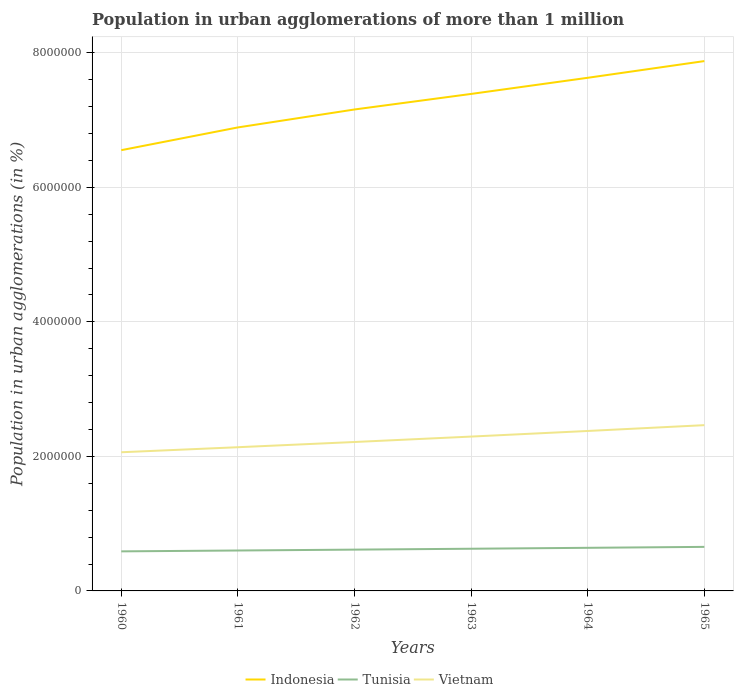Across all years, what is the maximum population in urban agglomerations in Tunisia?
Give a very brief answer. 5.88e+05. What is the total population in urban agglomerations in Vietnam in the graph?
Make the answer very short. -1.58e+05. What is the difference between the highest and the second highest population in urban agglomerations in Indonesia?
Keep it short and to the point. 1.32e+06. What is the difference between the highest and the lowest population in urban agglomerations in Tunisia?
Provide a succinct answer. 3. Is the population in urban agglomerations in Tunisia strictly greater than the population in urban agglomerations in Vietnam over the years?
Your answer should be compact. Yes. How many lines are there?
Provide a succinct answer. 3. What is the title of the graph?
Keep it short and to the point. Population in urban agglomerations of more than 1 million. What is the label or title of the Y-axis?
Give a very brief answer. Population in urban agglomerations (in %). What is the Population in urban agglomerations (in %) in Indonesia in 1960?
Your answer should be very brief. 6.55e+06. What is the Population in urban agglomerations (in %) in Tunisia in 1960?
Your answer should be very brief. 5.88e+05. What is the Population in urban agglomerations (in %) of Vietnam in 1960?
Make the answer very short. 2.06e+06. What is the Population in urban agglomerations (in %) of Indonesia in 1961?
Your answer should be very brief. 6.89e+06. What is the Population in urban agglomerations (in %) in Tunisia in 1961?
Provide a succinct answer. 6.01e+05. What is the Population in urban agglomerations (in %) of Vietnam in 1961?
Provide a short and direct response. 2.14e+06. What is the Population in urban agglomerations (in %) of Indonesia in 1962?
Your response must be concise. 7.16e+06. What is the Population in urban agglomerations (in %) in Tunisia in 1962?
Offer a very short reply. 6.14e+05. What is the Population in urban agglomerations (in %) of Vietnam in 1962?
Your answer should be compact. 2.21e+06. What is the Population in urban agglomerations (in %) in Indonesia in 1963?
Provide a succinct answer. 7.39e+06. What is the Population in urban agglomerations (in %) of Tunisia in 1963?
Keep it short and to the point. 6.27e+05. What is the Population in urban agglomerations (in %) of Vietnam in 1963?
Provide a short and direct response. 2.29e+06. What is the Population in urban agglomerations (in %) of Indonesia in 1964?
Your answer should be compact. 7.63e+06. What is the Population in urban agglomerations (in %) of Tunisia in 1964?
Offer a very short reply. 6.41e+05. What is the Population in urban agglomerations (in %) of Vietnam in 1964?
Offer a very short reply. 2.38e+06. What is the Population in urban agglomerations (in %) of Indonesia in 1965?
Your answer should be very brief. 7.88e+06. What is the Population in urban agglomerations (in %) in Tunisia in 1965?
Give a very brief answer. 6.55e+05. What is the Population in urban agglomerations (in %) of Vietnam in 1965?
Make the answer very short. 2.46e+06. Across all years, what is the maximum Population in urban agglomerations (in %) of Indonesia?
Offer a terse response. 7.88e+06. Across all years, what is the maximum Population in urban agglomerations (in %) in Tunisia?
Offer a very short reply. 6.55e+05. Across all years, what is the maximum Population in urban agglomerations (in %) in Vietnam?
Your answer should be compact. 2.46e+06. Across all years, what is the minimum Population in urban agglomerations (in %) of Indonesia?
Give a very brief answer. 6.55e+06. Across all years, what is the minimum Population in urban agglomerations (in %) of Tunisia?
Offer a very short reply. 5.88e+05. Across all years, what is the minimum Population in urban agglomerations (in %) in Vietnam?
Your answer should be compact. 2.06e+06. What is the total Population in urban agglomerations (in %) of Indonesia in the graph?
Offer a very short reply. 4.35e+07. What is the total Population in urban agglomerations (in %) in Tunisia in the graph?
Offer a very short reply. 3.73e+06. What is the total Population in urban agglomerations (in %) in Vietnam in the graph?
Keep it short and to the point. 1.36e+07. What is the difference between the Population in urban agglomerations (in %) of Indonesia in 1960 and that in 1961?
Offer a very short reply. -3.38e+05. What is the difference between the Population in urban agglomerations (in %) in Tunisia in 1960 and that in 1961?
Keep it short and to the point. -1.27e+04. What is the difference between the Population in urban agglomerations (in %) in Vietnam in 1960 and that in 1961?
Provide a succinct answer. -7.48e+04. What is the difference between the Population in urban agglomerations (in %) of Indonesia in 1960 and that in 1962?
Offer a terse response. -6.05e+05. What is the difference between the Population in urban agglomerations (in %) in Tunisia in 1960 and that in 1962?
Give a very brief answer. -2.58e+04. What is the difference between the Population in urban agglomerations (in %) of Vietnam in 1960 and that in 1962?
Make the answer very short. -1.52e+05. What is the difference between the Population in urban agglomerations (in %) of Indonesia in 1960 and that in 1963?
Provide a short and direct response. -8.36e+05. What is the difference between the Population in urban agglomerations (in %) in Tunisia in 1960 and that in 1963?
Provide a short and direct response. -3.91e+04. What is the difference between the Population in urban agglomerations (in %) in Vietnam in 1960 and that in 1963?
Give a very brief answer. -2.33e+05. What is the difference between the Population in urban agglomerations (in %) of Indonesia in 1960 and that in 1964?
Give a very brief answer. -1.08e+06. What is the difference between the Population in urban agglomerations (in %) of Tunisia in 1960 and that in 1964?
Make the answer very short. -5.27e+04. What is the difference between the Population in urban agglomerations (in %) in Vietnam in 1960 and that in 1964?
Your response must be concise. -3.16e+05. What is the difference between the Population in urban agglomerations (in %) of Indonesia in 1960 and that in 1965?
Offer a terse response. -1.32e+06. What is the difference between the Population in urban agglomerations (in %) in Tunisia in 1960 and that in 1965?
Ensure brevity in your answer.  -6.66e+04. What is the difference between the Population in urban agglomerations (in %) in Vietnam in 1960 and that in 1965?
Give a very brief answer. -4.03e+05. What is the difference between the Population in urban agglomerations (in %) in Indonesia in 1961 and that in 1962?
Ensure brevity in your answer.  -2.67e+05. What is the difference between the Population in urban agglomerations (in %) in Tunisia in 1961 and that in 1962?
Ensure brevity in your answer.  -1.30e+04. What is the difference between the Population in urban agglomerations (in %) in Vietnam in 1961 and that in 1962?
Your answer should be very brief. -7.76e+04. What is the difference between the Population in urban agglomerations (in %) in Indonesia in 1961 and that in 1963?
Give a very brief answer. -4.98e+05. What is the difference between the Population in urban agglomerations (in %) in Tunisia in 1961 and that in 1963?
Give a very brief answer. -2.63e+04. What is the difference between the Population in urban agglomerations (in %) in Vietnam in 1961 and that in 1963?
Offer a very short reply. -1.58e+05. What is the difference between the Population in urban agglomerations (in %) of Indonesia in 1961 and that in 1964?
Your answer should be compact. -7.38e+05. What is the difference between the Population in urban agglomerations (in %) in Tunisia in 1961 and that in 1964?
Your answer should be compact. -4.00e+04. What is the difference between the Population in urban agglomerations (in %) of Vietnam in 1961 and that in 1964?
Provide a short and direct response. -2.42e+05. What is the difference between the Population in urban agglomerations (in %) in Indonesia in 1961 and that in 1965?
Your answer should be very brief. -9.86e+05. What is the difference between the Population in urban agglomerations (in %) in Tunisia in 1961 and that in 1965?
Offer a terse response. -5.38e+04. What is the difference between the Population in urban agglomerations (in %) of Vietnam in 1961 and that in 1965?
Provide a succinct answer. -3.28e+05. What is the difference between the Population in urban agglomerations (in %) of Indonesia in 1962 and that in 1963?
Your answer should be very brief. -2.31e+05. What is the difference between the Population in urban agglomerations (in %) in Tunisia in 1962 and that in 1963?
Make the answer very short. -1.33e+04. What is the difference between the Population in urban agglomerations (in %) in Vietnam in 1962 and that in 1963?
Make the answer very short. -8.05e+04. What is the difference between the Population in urban agglomerations (in %) of Indonesia in 1962 and that in 1964?
Your response must be concise. -4.71e+05. What is the difference between the Population in urban agglomerations (in %) of Tunisia in 1962 and that in 1964?
Offer a very short reply. -2.69e+04. What is the difference between the Population in urban agglomerations (in %) in Vietnam in 1962 and that in 1964?
Offer a terse response. -1.64e+05. What is the difference between the Population in urban agglomerations (in %) in Indonesia in 1962 and that in 1965?
Give a very brief answer. -7.20e+05. What is the difference between the Population in urban agglomerations (in %) of Tunisia in 1962 and that in 1965?
Your response must be concise. -4.08e+04. What is the difference between the Population in urban agglomerations (in %) in Vietnam in 1962 and that in 1965?
Provide a succinct answer. -2.50e+05. What is the difference between the Population in urban agglomerations (in %) in Indonesia in 1963 and that in 1964?
Give a very brief answer. -2.40e+05. What is the difference between the Population in urban agglomerations (in %) of Tunisia in 1963 and that in 1964?
Make the answer very short. -1.36e+04. What is the difference between the Population in urban agglomerations (in %) in Vietnam in 1963 and that in 1964?
Your answer should be compact. -8.35e+04. What is the difference between the Population in urban agglomerations (in %) in Indonesia in 1963 and that in 1965?
Keep it short and to the point. -4.88e+05. What is the difference between the Population in urban agglomerations (in %) of Tunisia in 1963 and that in 1965?
Provide a succinct answer. -2.75e+04. What is the difference between the Population in urban agglomerations (in %) of Vietnam in 1963 and that in 1965?
Ensure brevity in your answer.  -1.70e+05. What is the difference between the Population in urban agglomerations (in %) in Indonesia in 1964 and that in 1965?
Make the answer very short. -2.48e+05. What is the difference between the Population in urban agglomerations (in %) of Tunisia in 1964 and that in 1965?
Provide a succinct answer. -1.39e+04. What is the difference between the Population in urban agglomerations (in %) of Vietnam in 1964 and that in 1965?
Give a very brief answer. -8.63e+04. What is the difference between the Population in urban agglomerations (in %) in Indonesia in 1960 and the Population in urban agglomerations (in %) in Tunisia in 1961?
Offer a very short reply. 5.95e+06. What is the difference between the Population in urban agglomerations (in %) of Indonesia in 1960 and the Population in urban agglomerations (in %) of Vietnam in 1961?
Your response must be concise. 4.42e+06. What is the difference between the Population in urban agglomerations (in %) in Tunisia in 1960 and the Population in urban agglomerations (in %) in Vietnam in 1961?
Keep it short and to the point. -1.55e+06. What is the difference between the Population in urban agglomerations (in %) of Indonesia in 1960 and the Population in urban agglomerations (in %) of Tunisia in 1962?
Provide a succinct answer. 5.94e+06. What is the difference between the Population in urban agglomerations (in %) in Indonesia in 1960 and the Population in urban agglomerations (in %) in Vietnam in 1962?
Keep it short and to the point. 4.34e+06. What is the difference between the Population in urban agglomerations (in %) of Tunisia in 1960 and the Population in urban agglomerations (in %) of Vietnam in 1962?
Your response must be concise. -1.63e+06. What is the difference between the Population in urban agglomerations (in %) of Indonesia in 1960 and the Population in urban agglomerations (in %) of Tunisia in 1963?
Your response must be concise. 5.93e+06. What is the difference between the Population in urban agglomerations (in %) of Indonesia in 1960 and the Population in urban agglomerations (in %) of Vietnam in 1963?
Offer a terse response. 4.26e+06. What is the difference between the Population in urban agglomerations (in %) in Tunisia in 1960 and the Population in urban agglomerations (in %) in Vietnam in 1963?
Your response must be concise. -1.71e+06. What is the difference between the Population in urban agglomerations (in %) in Indonesia in 1960 and the Population in urban agglomerations (in %) in Tunisia in 1964?
Your answer should be compact. 5.91e+06. What is the difference between the Population in urban agglomerations (in %) of Indonesia in 1960 and the Population in urban agglomerations (in %) of Vietnam in 1964?
Your response must be concise. 4.17e+06. What is the difference between the Population in urban agglomerations (in %) of Tunisia in 1960 and the Population in urban agglomerations (in %) of Vietnam in 1964?
Ensure brevity in your answer.  -1.79e+06. What is the difference between the Population in urban agglomerations (in %) of Indonesia in 1960 and the Population in urban agglomerations (in %) of Tunisia in 1965?
Give a very brief answer. 5.90e+06. What is the difference between the Population in urban agglomerations (in %) of Indonesia in 1960 and the Population in urban agglomerations (in %) of Vietnam in 1965?
Offer a terse response. 4.09e+06. What is the difference between the Population in urban agglomerations (in %) of Tunisia in 1960 and the Population in urban agglomerations (in %) of Vietnam in 1965?
Your answer should be very brief. -1.88e+06. What is the difference between the Population in urban agglomerations (in %) in Indonesia in 1961 and the Population in urban agglomerations (in %) in Tunisia in 1962?
Your answer should be very brief. 6.28e+06. What is the difference between the Population in urban agglomerations (in %) of Indonesia in 1961 and the Population in urban agglomerations (in %) of Vietnam in 1962?
Provide a short and direct response. 4.68e+06. What is the difference between the Population in urban agglomerations (in %) in Tunisia in 1961 and the Population in urban agglomerations (in %) in Vietnam in 1962?
Your answer should be compact. -1.61e+06. What is the difference between the Population in urban agglomerations (in %) of Indonesia in 1961 and the Population in urban agglomerations (in %) of Tunisia in 1963?
Give a very brief answer. 6.26e+06. What is the difference between the Population in urban agglomerations (in %) of Indonesia in 1961 and the Population in urban agglomerations (in %) of Vietnam in 1963?
Give a very brief answer. 4.60e+06. What is the difference between the Population in urban agglomerations (in %) in Tunisia in 1961 and the Population in urban agglomerations (in %) in Vietnam in 1963?
Your answer should be compact. -1.69e+06. What is the difference between the Population in urban agglomerations (in %) in Indonesia in 1961 and the Population in urban agglomerations (in %) in Tunisia in 1964?
Your answer should be compact. 6.25e+06. What is the difference between the Population in urban agglomerations (in %) of Indonesia in 1961 and the Population in urban agglomerations (in %) of Vietnam in 1964?
Make the answer very short. 4.51e+06. What is the difference between the Population in urban agglomerations (in %) of Tunisia in 1961 and the Population in urban agglomerations (in %) of Vietnam in 1964?
Keep it short and to the point. -1.78e+06. What is the difference between the Population in urban agglomerations (in %) in Indonesia in 1961 and the Population in urban agglomerations (in %) in Tunisia in 1965?
Keep it short and to the point. 6.24e+06. What is the difference between the Population in urban agglomerations (in %) of Indonesia in 1961 and the Population in urban agglomerations (in %) of Vietnam in 1965?
Your answer should be very brief. 4.43e+06. What is the difference between the Population in urban agglomerations (in %) in Tunisia in 1961 and the Population in urban agglomerations (in %) in Vietnam in 1965?
Provide a short and direct response. -1.86e+06. What is the difference between the Population in urban agglomerations (in %) in Indonesia in 1962 and the Population in urban agglomerations (in %) in Tunisia in 1963?
Your response must be concise. 6.53e+06. What is the difference between the Population in urban agglomerations (in %) in Indonesia in 1962 and the Population in urban agglomerations (in %) in Vietnam in 1963?
Give a very brief answer. 4.86e+06. What is the difference between the Population in urban agglomerations (in %) of Tunisia in 1962 and the Population in urban agglomerations (in %) of Vietnam in 1963?
Your answer should be compact. -1.68e+06. What is the difference between the Population in urban agglomerations (in %) of Indonesia in 1962 and the Population in urban agglomerations (in %) of Tunisia in 1964?
Make the answer very short. 6.52e+06. What is the difference between the Population in urban agglomerations (in %) of Indonesia in 1962 and the Population in urban agglomerations (in %) of Vietnam in 1964?
Provide a succinct answer. 4.78e+06. What is the difference between the Population in urban agglomerations (in %) in Tunisia in 1962 and the Population in urban agglomerations (in %) in Vietnam in 1964?
Provide a short and direct response. -1.76e+06. What is the difference between the Population in urban agglomerations (in %) of Indonesia in 1962 and the Population in urban agglomerations (in %) of Tunisia in 1965?
Your answer should be very brief. 6.50e+06. What is the difference between the Population in urban agglomerations (in %) in Indonesia in 1962 and the Population in urban agglomerations (in %) in Vietnam in 1965?
Offer a terse response. 4.69e+06. What is the difference between the Population in urban agglomerations (in %) in Tunisia in 1962 and the Population in urban agglomerations (in %) in Vietnam in 1965?
Your answer should be very brief. -1.85e+06. What is the difference between the Population in urban agglomerations (in %) in Indonesia in 1963 and the Population in urban agglomerations (in %) in Tunisia in 1964?
Keep it short and to the point. 6.75e+06. What is the difference between the Population in urban agglomerations (in %) in Indonesia in 1963 and the Population in urban agglomerations (in %) in Vietnam in 1964?
Offer a terse response. 5.01e+06. What is the difference between the Population in urban agglomerations (in %) of Tunisia in 1963 and the Population in urban agglomerations (in %) of Vietnam in 1964?
Provide a short and direct response. -1.75e+06. What is the difference between the Population in urban agglomerations (in %) of Indonesia in 1963 and the Population in urban agglomerations (in %) of Tunisia in 1965?
Provide a short and direct response. 6.73e+06. What is the difference between the Population in urban agglomerations (in %) in Indonesia in 1963 and the Population in urban agglomerations (in %) in Vietnam in 1965?
Provide a short and direct response. 4.92e+06. What is the difference between the Population in urban agglomerations (in %) in Tunisia in 1963 and the Population in urban agglomerations (in %) in Vietnam in 1965?
Ensure brevity in your answer.  -1.84e+06. What is the difference between the Population in urban agglomerations (in %) in Indonesia in 1964 and the Population in urban agglomerations (in %) in Tunisia in 1965?
Your answer should be compact. 6.97e+06. What is the difference between the Population in urban agglomerations (in %) of Indonesia in 1964 and the Population in urban agglomerations (in %) of Vietnam in 1965?
Your response must be concise. 5.16e+06. What is the difference between the Population in urban agglomerations (in %) of Tunisia in 1964 and the Population in urban agglomerations (in %) of Vietnam in 1965?
Give a very brief answer. -1.82e+06. What is the average Population in urban agglomerations (in %) in Indonesia per year?
Make the answer very short. 7.25e+06. What is the average Population in urban agglomerations (in %) in Tunisia per year?
Provide a succinct answer. 6.21e+05. What is the average Population in urban agglomerations (in %) of Vietnam per year?
Provide a succinct answer. 2.26e+06. In the year 1960, what is the difference between the Population in urban agglomerations (in %) in Indonesia and Population in urban agglomerations (in %) in Tunisia?
Provide a succinct answer. 5.96e+06. In the year 1960, what is the difference between the Population in urban agglomerations (in %) in Indonesia and Population in urban agglomerations (in %) in Vietnam?
Offer a terse response. 4.49e+06. In the year 1960, what is the difference between the Population in urban agglomerations (in %) of Tunisia and Population in urban agglomerations (in %) of Vietnam?
Offer a terse response. -1.47e+06. In the year 1961, what is the difference between the Population in urban agglomerations (in %) of Indonesia and Population in urban agglomerations (in %) of Tunisia?
Provide a short and direct response. 6.29e+06. In the year 1961, what is the difference between the Population in urban agglomerations (in %) of Indonesia and Population in urban agglomerations (in %) of Vietnam?
Keep it short and to the point. 4.75e+06. In the year 1961, what is the difference between the Population in urban agglomerations (in %) of Tunisia and Population in urban agglomerations (in %) of Vietnam?
Make the answer very short. -1.54e+06. In the year 1962, what is the difference between the Population in urban agglomerations (in %) in Indonesia and Population in urban agglomerations (in %) in Tunisia?
Ensure brevity in your answer.  6.54e+06. In the year 1962, what is the difference between the Population in urban agglomerations (in %) of Indonesia and Population in urban agglomerations (in %) of Vietnam?
Offer a terse response. 4.94e+06. In the year 1962, what is the difference between the Population in urban agglomerations (in %) in Tunisia and Population in urban agglomerations (in %) in Vietnam?
Ensure brevity in your answer.  -1.60e+06. In the year 1963, what is the difference between the Population in urban agglomerations (in %) of Indonesia and Population in urban agglomerations (in %) of Tunisia?
Keep it short and to the point. 6.76e+06. In the year 1963, what is the difference between the Population in urban agglomerations (in %) in Indonesia and Population in urban agglomerations (in %) in Vietnam?
Your response must be concise. 5.09e+06. In the year 1963, what is the difference between the Population in urban agglomerations (in %) of Tunisia and Population in urban agglomerations (in %) of Vietnam?
Give a very brief answer. -1.67e+06. In the year 1964, what is the difference between the Population in urban agglomerations (in %) in Indonesia and Population in urban agglomerations (in %) in Tunisia?
Your answer should be very brief. 6.99e+06. In the year 1964, what is the difference between the Population in urban agglomerations (in %) in Indonesia and Population in urban agglomerations (in %) in Vietnam?
Offer a very short reply. 5.25e+06. In the year 1964, what is the difference between the Population in urban agglomerations (in %) of Tunisia and Population in urban agglomerations (in %) of Vietnam?
Your response must be concise. -1.74e+06. In the year 1965, what is the difference between the Population in urban agglomerations (in %) in Indonesia and Population in urban agglomerations (in %) in Tunisia?
Offer a terse response. 7.22e+06. In the year 1965, what is the difference between the Population in urban agglomerations (in %) in Indonesia and Population in urban agglomerations (in %) in Vietnam?
Your response must be concise. 5.41e+06. In the year 1965, what is the difference between the Population in urban agglomerations (in %) in Tunisia and Population in urban agglomerations (in %) in Vietnam?
Ensure brevity in your answer.  -1.81e+06. What is the ratio of the Population in urban agglomerations (in %) in Indonesia in 1960 to that in 1961?
Offer a very short reply. 0.95. What is the ratio of the Population in urban agglomerations (in %) in Tunisia in 1960 to that in 1961?
Provide a succinct answer. 0.98. What is the ratio of the Population in urban agglomerations (in %) of Vietnam in 1960 to that in 1961?
Offer a terse response. 0.96. What is the ratio of the Population in urban agglomerations (in %) in Indonesia in 1960 to that in 1962?
Offer a terse response. 0.92. What is the ratio of the Population in urban agglomerations (in %) of Tunisia in 1960 to that in 1962?
Keep it short and to the point. 0.96. What is the ratio of the Population in urban agglomerations (in %) of Vietnam in 1960 to that in 1962?
Offer a terse response. 0.93. What is the ratio of the Population in urban agglomerations (in %) in Indonesia in 1960 to that in 1963?
Give a very brief answer. 0.89. What is the ratio of the Population in urban agglomerations (in %) of Tunisia in 1960 to that in 1963?
Your answer should be very brief. 0.94. What is the ratio of the Population in urban agglomerations (in %) in Vietnam in 1960 to that in 1963?
Provide a short and direct response. 0.9. What is the ratio of the Population in urban agglomerations (in %) in Indonesia in 1960 to that in 1964?
Ensure brevity in your answer.  0.86. What is the ratio of the Population in urban agglomerations (in %) in Tunisia in 1960 to that in 1964?
Provide a short and direct response. 0.92. What is the ratio of the Population in urban agglomerations (in %) in Vietnam in 1960 to that in 1964?
Provide a succinct answer. 0.87. What is the ratio of the Population in urban agglomerations (in %) of Indonesia in 1960 to that in 1965?
Give a very brief answer. 0.83. What is the ratio of the Population in urban agglomerations (in %) of Tunisia in 1960 to that in 1965?
Ensure brevity in your answer.  0.9. What is the ratio of the Population in urban agglomerations (in %) of Vietnam in 1960 to that in 1965?
Your response must be concise. 0.84. What is the ratio of the Population in urban agglomerations (in %) of Indonesia in 1961 to that in 1962?
Provide a succinct answer. 0.96. What is the ratio of the Population in urban agglomerations (in %) of Tunisia in 1961 to that in 1962?
Keep it short and to the point. 0.98. What is the ratio of the Population in urban agglomerations (in %) in Vietnam in 1961 to that in 1962?
Ensure brevity in your answer.  0.96. What is the ratio of the Population in urban agglomerations (in %) in Indonesia in 1961 to that in 1963?
Make the answer very short. 0.93. What is the ratio of the Population in urban agglomerations (in %) in Tunisia in 1961 to that in 1963?
Offer a very short reply. 0.96. What is the ratio of the Population in urban agglomerations (in %) of Vietnam in 1961 to that in 1963?
Ensure brevity in your answer.  0.93. What is the ratio of the Population in urban agglomerations (in %) of Indonesia in 1961 to that in 1964?
Keep it short and to the point. 0.9. What is the ratio of the Population in urban agglomerations (in %) of Tunisia in 1961 to that in 1964?
Your answer should be very brief. 0.94. What is the ratio of the Population in urban agglomerations (in %) in Vietnam in 1961 to that in 1964?
Your answer should be compact. 0.9. What is the ratio of the Population in urban agglomerations (in %) of Indonesia in 1961 to that in 1965?
Keep it short and to the point. 0.87. What is the ratio of the Population in urban agglomerations (in %) of Tunisia in 1961 to that in 1965?
Offer a terse response. 0.92. What is the ratio of the Population in urban agglomerations (in %) of Vietnam in 1961 to that in 1965?
Your response must be concise. 0.87. What is the ratio of the Population in urban agglomerations (in %) in Indonesia in 1962 to that in 1963?
Give a very brief answer. 0.97. What is the ratio of the Population in urban agglomerations (in %) in Tunisia in 1962 to that in 1963?
Keep it short and to the point. 0.98. What is the ratio of the Population in urban agglomerations (in %) in Vietnam in 1962 to that in 1963?
Your answer should be very brief. 0.96. What is the ratio of the Population in urban agglomerations (in %) of Indonesia in 1962 to that in 1964?
Ensure brevity in your answer.  0.94. What is the ratio of the Population in urban agglomerations (in %) of Tunisia in 1962 to that in 1964?
Make the answer very short. 0.96. What is the ratio of the Population in urban agglomerations (in %) in Vietnam in 1962 to that in 1964?
Your answer should be very brief. 0.93. What is the ratio of the Population in urban agglomerations (in %) in Indonesia in 1962 to that in 1965?
Give a very brief answer. 0.91. What is the ratio of the Population in urban agglomerations (in %) in Tunisia in 1962 to that in 1965?
Make the answer very short. 0.94. What is the ratio of the Population in urban agglomerations (in %) in Vietnam in 1962 to that in 1965?
Make the answer very short. 0.9. What is the ratio of the Population in urban agglomerations (in %) of Indonesia in 1963 to that in 1964?
Your response must be concise. 0.97. What is the ratio of the Population in urban agglomerations (in %) of Tunisia in 1963 to that in 1964?
Provide a succinct answer. 0.98. What is the ratio of the Population in urban agglomerations (in %) of Vietnam in 1963 to that in 1964?
Provide a succinct answer. 0.96. What is the ratio of the Population in urban agglomerations (in %) in Indonesia in 1963 to that in 1965?
Offer a very short reply. 0.94. What is the ratio of the Population in urban agglomerations (in %) in Tunisia in 1963 to that in 1965?
Provide a succinct answer. 0.96. What is the ratio of the Population in urban agglomerations (in %) in Vietnam in 1963 to that in 1965?
Your answer should be compact. 0.93. What is the ratio of the Population in urban agglomerations (in %) of Indonesia in 1964 to that in 1965?
Ensure brevity in your answer.  0.97. What is the ratio of the Population in urban agglomerations (in %) of Tunisia in 1964 to that in 1965?
Keep it short and to the point. 0.98. What is the ratio of the Population in urban agglomerations (in %) in Vietnam in 1964 to that in 1965?
Ensure brevity in your answer.  0.96. What is the difference between the highest and the second highest Population in urban agglomerations (in %) in Indonesia?
Offer a terse response. 2.48e+05. What is the difference between the highest and the second highest Population in urban agglomerations (in %) in Tunisia?
Make the answer very short. 1.39e+04. What is the difference between the highest and the second highest Population in urban agglomerations (in %) of Vietnam?
Ensure brevity in your answer.  8.63e+04. What is the difference between the highest and the lowest Population in urban agglomerations (in %) of Indonesia?
Make the answer very short. 1.32e+06. What is the difference between the highest and the lowest Population in urban agglomerations (in %) of Tunisia?
Offer a very short reply. 6.66e+04. What is the difference between the highest and the lowest Population in urban agglomerations (in %) of Vietnam?
Your answer should be very brief. 4.03e+05. 